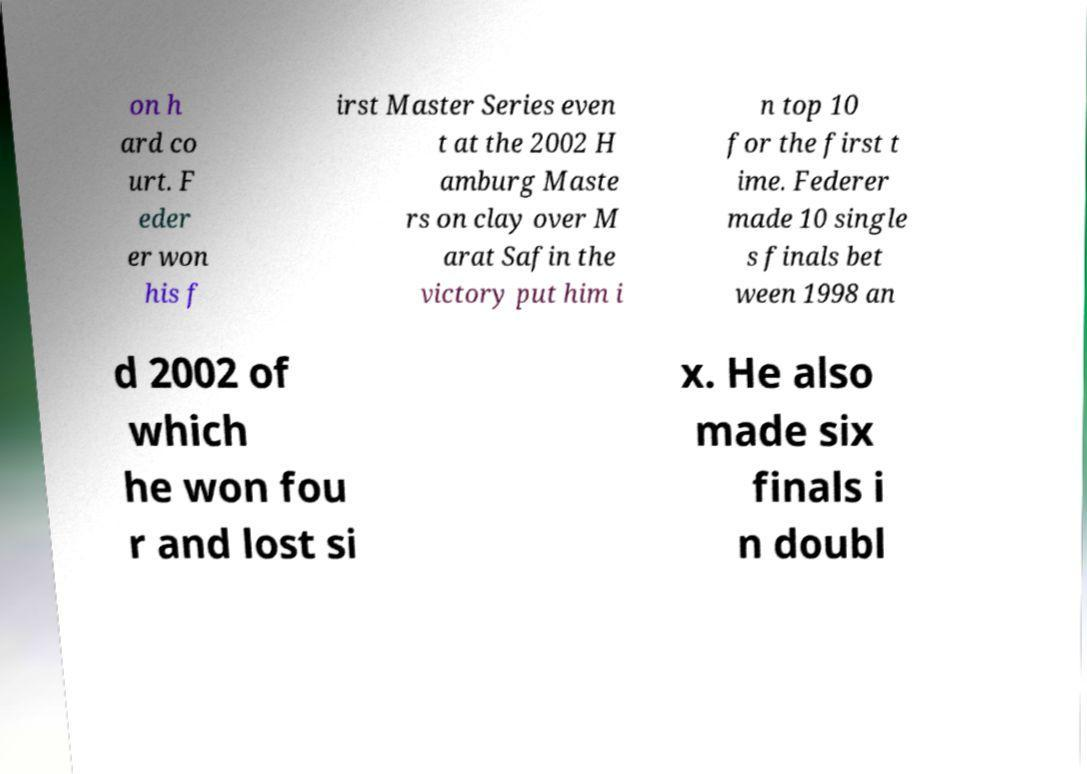What messages or text are displayed in this image? I need them in a readable, typed format. on h ard co urt. F eder er won his f irst Master Series even t at the 2002 H amburg Maste rs on clay over M arat Safin the victory put him i n top 10 for the first t ime. Federer made 10 single s finals bet ween 1998 an d 2002 of which he won fou r and lost si x. He also made six finals i n doubl 